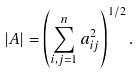<formula> <loc_0><loc_0><loc_500><loc_500>\left | A \right | = \left ( \sum _ { i , j = 1 } ^ { n } a _ { i j } ^ { 2 } \right ) ^ { 1 / 2 } .</formula> 